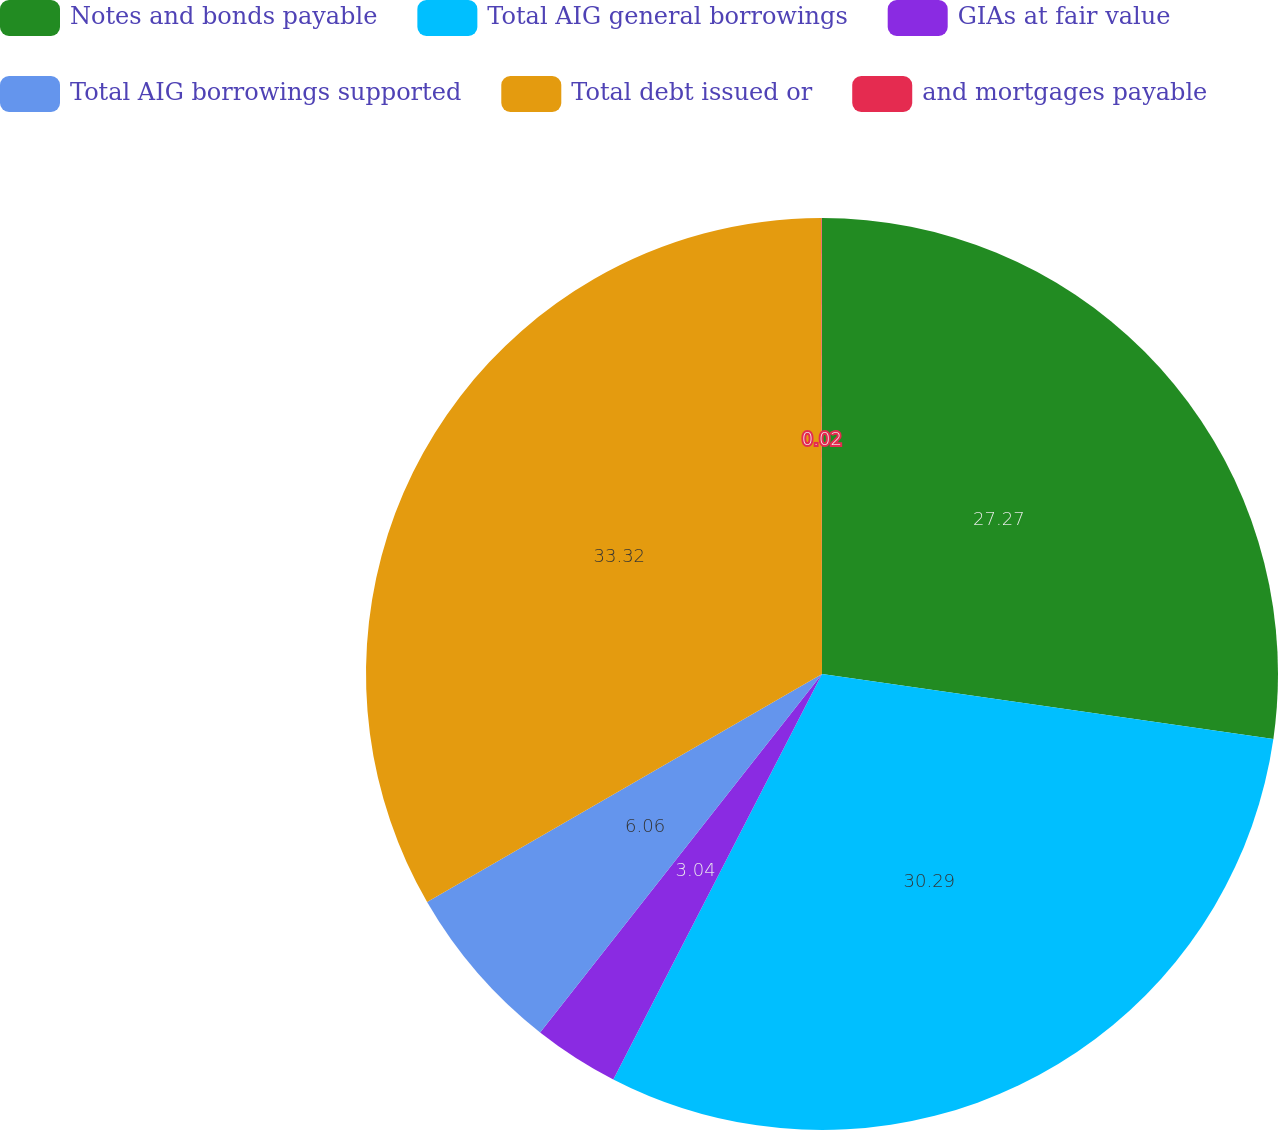Convert chart to OTSL. <chart><loc_0><loc_0><loc_500><loc_500><pie_chart><fcel>Notes and bonds payable<fcel>Total AIG general borrowings<fcel>GIAs at fair value<fcel>Total AIG borrowings supported<fcel>Total debt issued or<fcel>and mortgages payable<nl><fcel>27.27%<fcel>30.29%<fcel>3.04%<fcel>6.06%<fcel>33.31%<fcel>0.02%<nl></chart> 